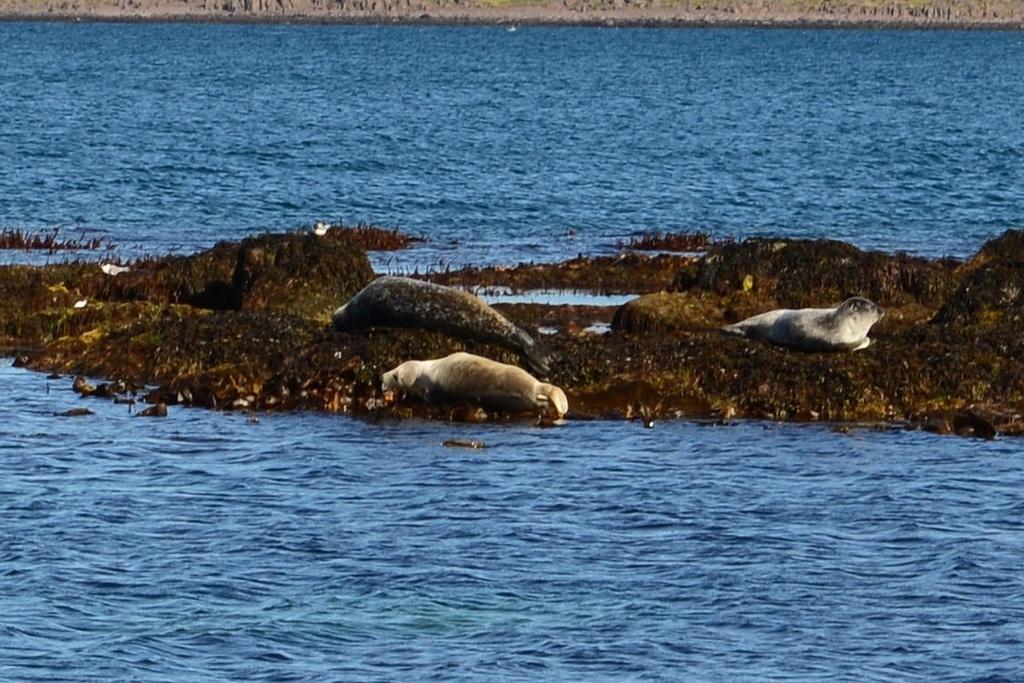Could you give a brief overview of what you see in this image? In this image we can see some animals on the rock. We can also see some plants and a large water body. 